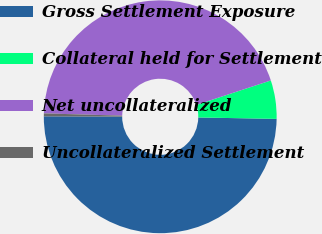Convert chart to OTSL. <chart><loc_0><loc_0><loc_500><loc_500><pie_chart><fcel>Gross Settlement Exposure<fcel>Collateral held for Settlement<fcel>Net uncollateralized<fcel>Uncollateralized Settlement<nl><fcel>49.77%<fcel>5.34%<fcel>44.48%<fcel>0.4%<nl></chart> 